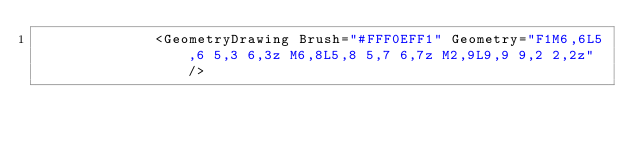Convert code to text. <code><loc_0><loc_0><loc_500><loc_500><_XML_>              <GeometryDrawing Brush="#FFF0EFF1" Geometry="F1M6,6L5,6 5,3 6,3z M6,8L5,8 5,7 6,7z M2,9L9,9 9,2 2,2z" /></code> 